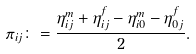<formula> <loc_0><loc_0><loc_500><loc_500>\pi _ { i j } \colon = \frac { \eta ^ { m } _ { i j } + \eta ^ { f } _ { i j } - \eta ^ { m } _ { i 0 } - \eta ^ { f } _ { 0 j } } { 2 } .</formula> 